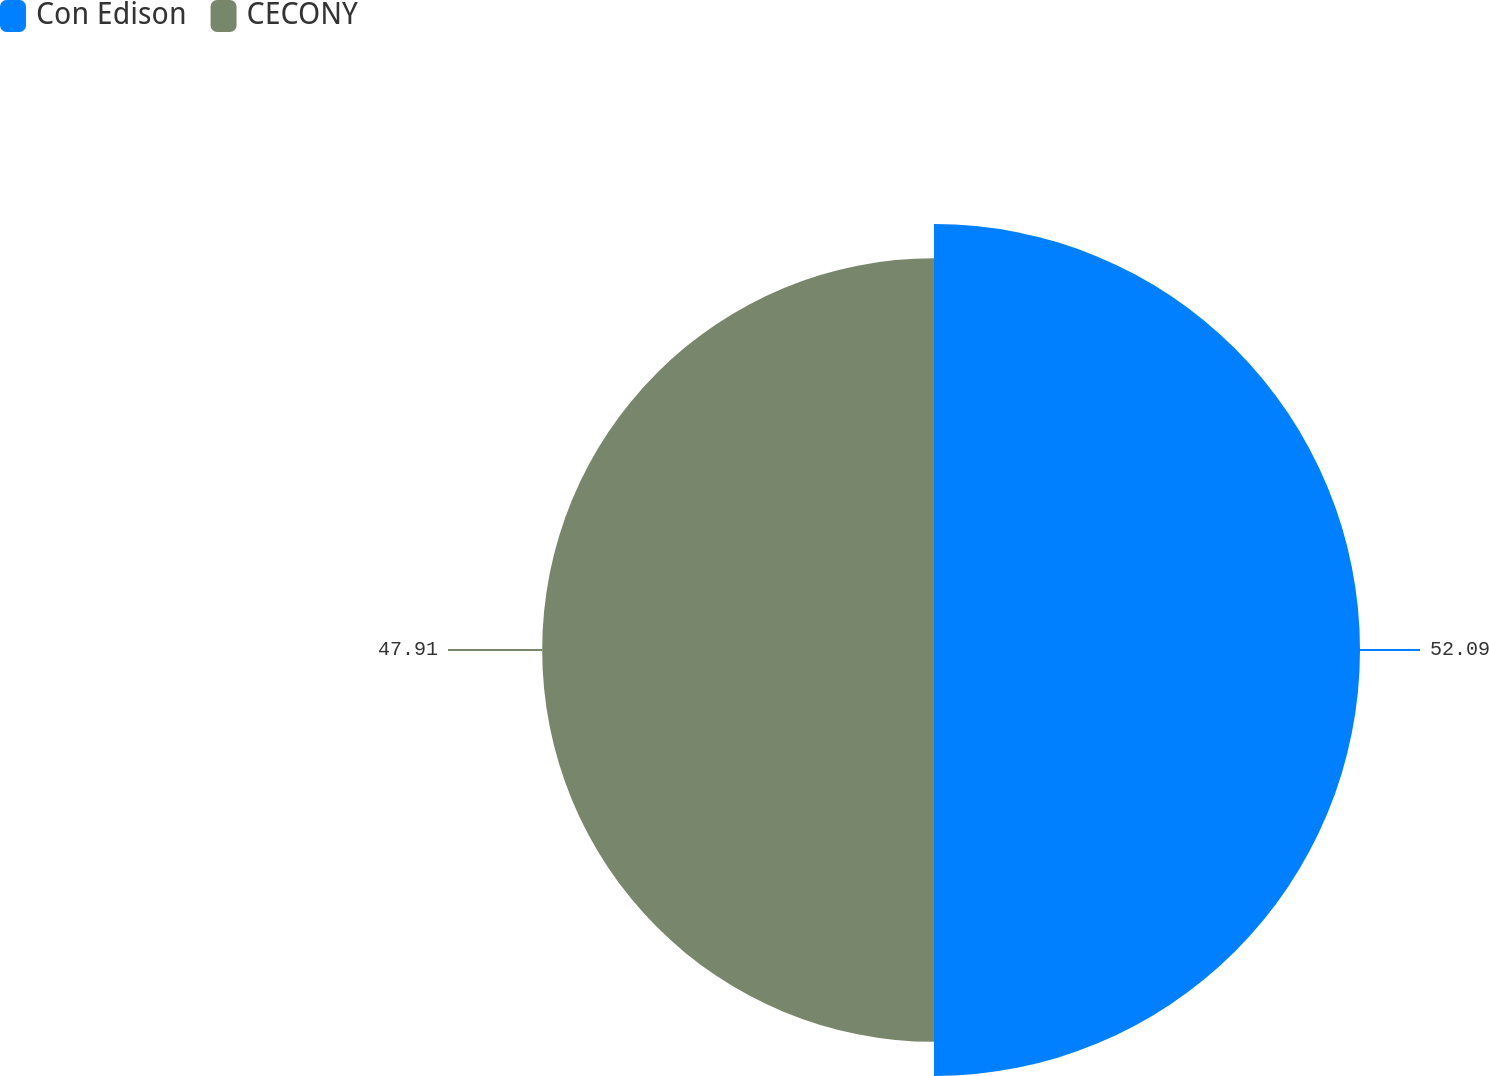<chart> <loc_0><loc_0><loc_500><loc_500><pie_chart><fcel>Con Edison<fcel>CECONY<nl><fcel>52.09%<fcel>47.91%<nl></chart> 